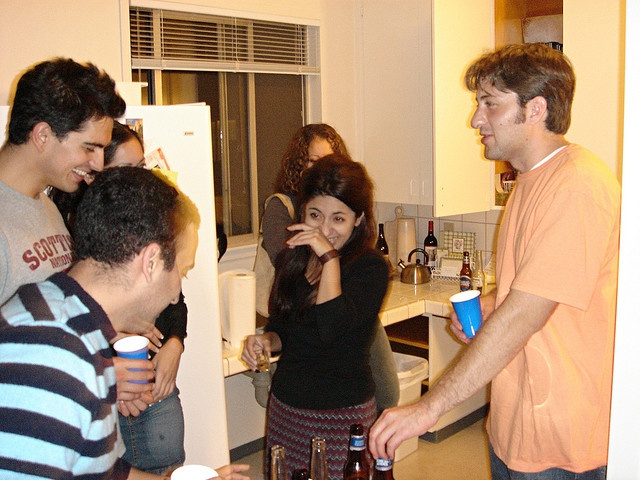Describe the objects in this image and their specific colors. I can see people in tan and maroon tones, people in tan, black, and lightblue tones, people in tan, black, maroon, and gray tones, people in tan, black, darkgray, and brown tones, and refrigerator in tan and beige tones in this image. 